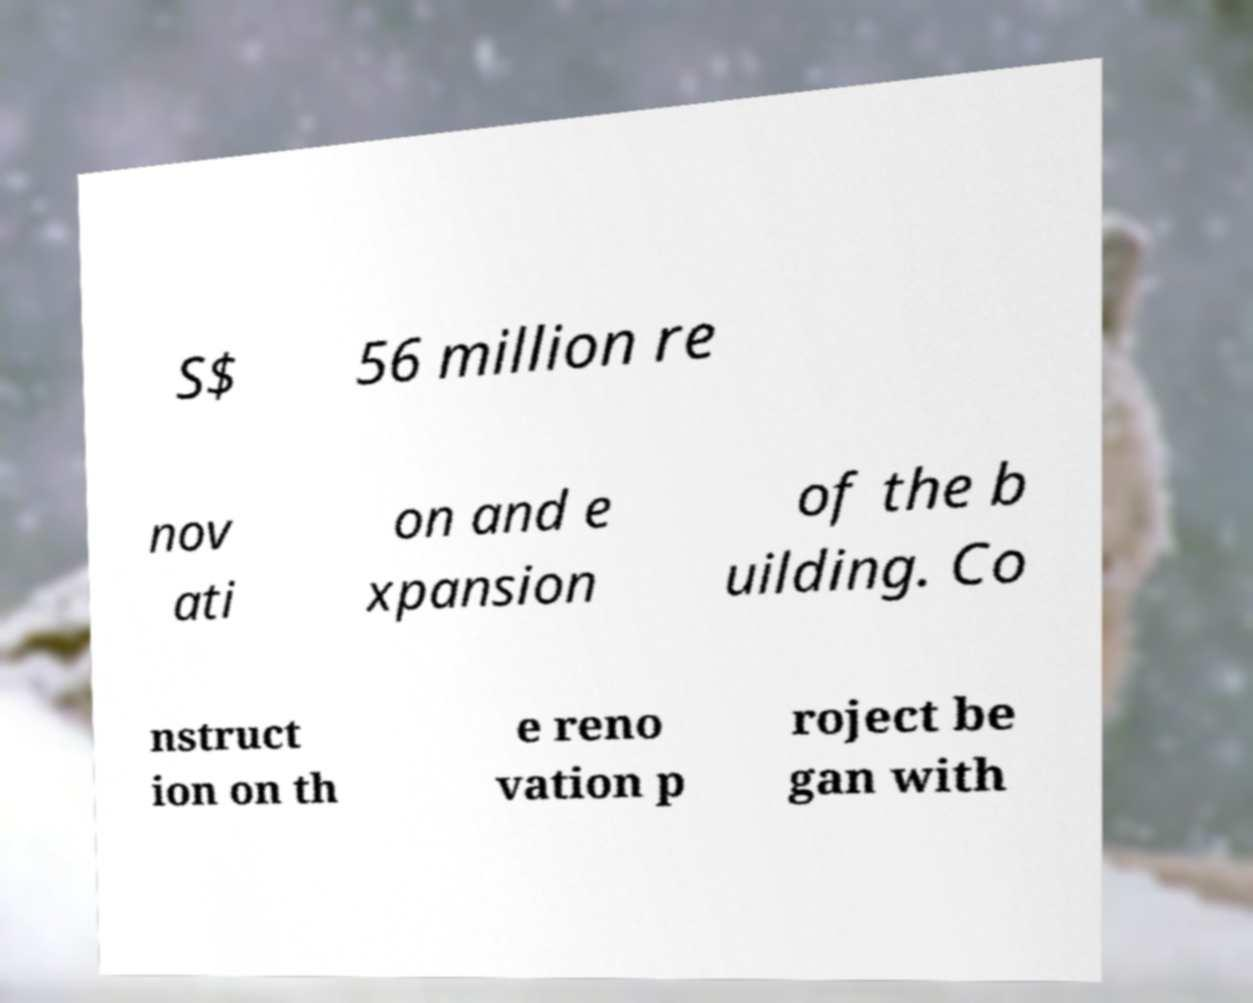There's text embedded in this image that I need extracted. Can you transcribe it verbatim? S$ 56 million re nov ati on and e xpansion of the b uilding. Co nstruct ion on th e reno vation p roject be gan with 